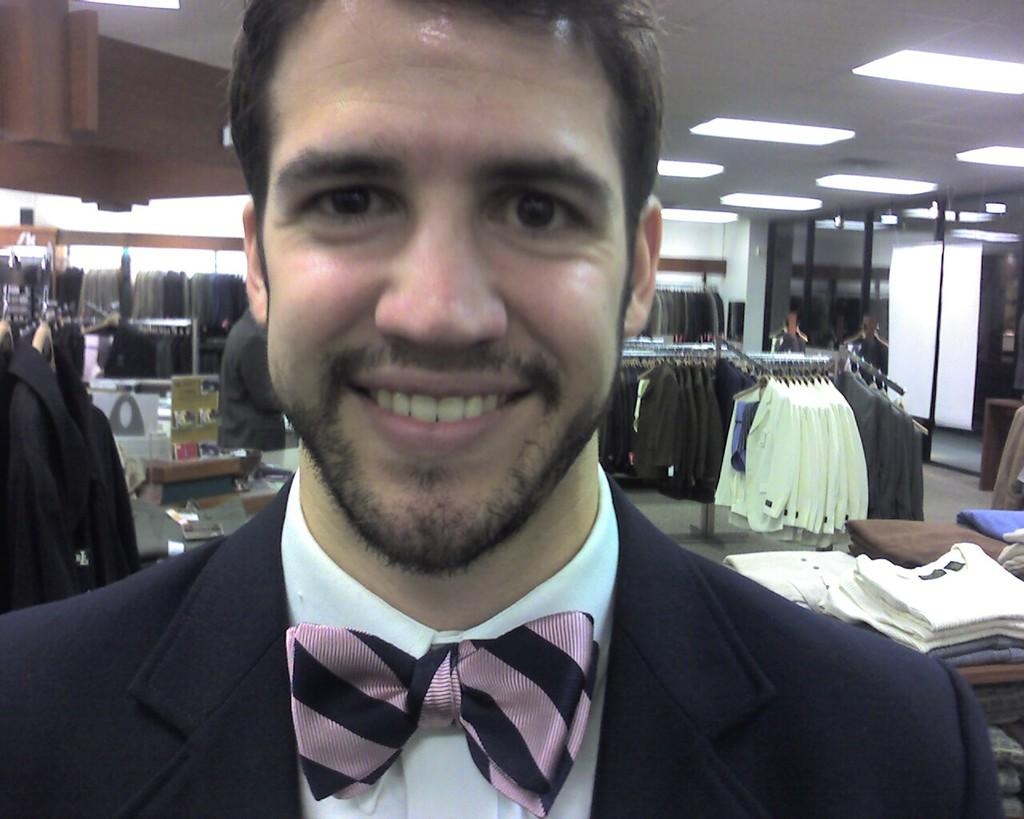Who is the main subject in the image? There is a person in the front of the image. What is the person doing in the image? The person is smiling. What can be seen in the background of the image? There are clothes, lights, other persons, and a wall in the background of the image. What type of seed is being planted by the person in the image? There is no seed or planting activity present in the image; the person is simply smiling. 